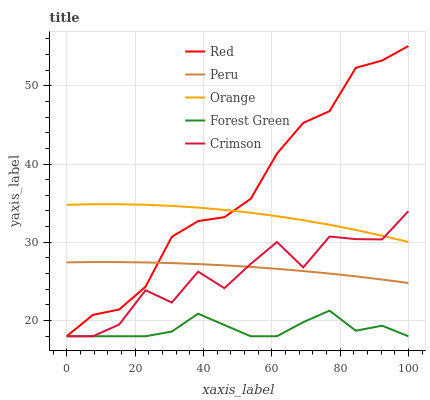Does Forest Green have the minimum area under the curve?
Answer yes or no. Yes. Does Red have the maximum area under the curve?
Answer yes or no. Yes. Does Crimson have the minimum area under the curve?
Answer yes or no. No. Does Crimson have the maximum area under the curve?
Answer yes or no. No. Is Peru the smoothest?
Answer yes or no. Yes. Is Crimson the roughest?
Answer yes or no. Yes. Is Forest Green the smoothest?
Answer yes or no. No. Is Forest Green the roughest?
Answer yes or no. No. Does Crimson have the lowest value?
Answer yes or no. Yes. Does Peru have the lowest value?
Answer yes or no. No. Does Red have the highest value?
Answer yes or no. Yes. Does Crimson have the highest value?
Answer yes or no. No. Is Forest Green less than Orange?
Answer yes or no. Yes. Is Orange greater than Peru?
Answer yes or no. Yes. Does Red intersect Forest Green?
Answer yes or no. Yes. Is Red less than Forest Green?
Answer yes or no. No. Is Red greater than Forest Green?
Answer yes or no. No. Does Forest Green intersect Orange?
Answer yes or no. No. 